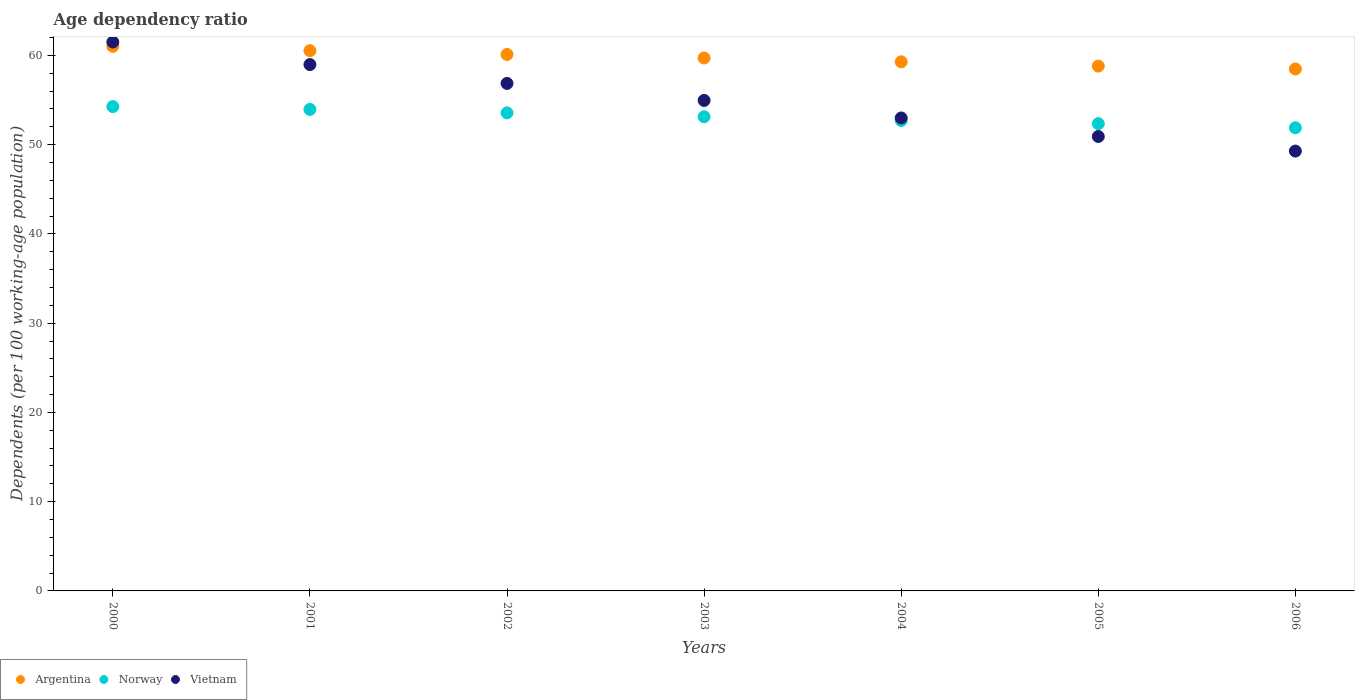Is the number of dotlines equal to the number of legend labels?
Provide a succinct answer. Yes. What is the age dependency ratio in in Argentina in 2004?
Keep it short and to the point. 59.28. Across all years, what is the maximum age dependency ratio in in Argentina?
Give a very brief answer. 61.02. Across all years, what is the minimum age dependency ratio in in Argentina?
Give a very brief answer. 58.48. In which year was the age dependency ratio in in Vietnam maximum?
Make the answer very short. 2000. What is the total age dependency ratio in in Vietnam in the graph?
Offer a very short reply. 385.49. What is the difference between the age dependency ratio in in Argentina in 2002 and that in 2005?
Provide a short and direct response. 1.31. What is the difference between the age dependency ratio in in Norway in 2006 and the age dependency ratio in in Argentina in 2000?
Ensure brevity in your answer.  -9.13. What is the average age dependency ratio in in Norway per year?
Give a very brief answer. 53.12. In the year 2000, what is the difference between the age dependency ratio in in Argentina and age dependency ratio in in Vietnam?
Offer a terse response. -0.48. In how many years, is the age dependency ratio in in Norway greater than 52 %?
Provide a short and direct response. 6. What is the ratio of the age dependency ratio in in Norway in 2002 to that in 2006?
Keep it short and to the point. 1.03. Is the age dependency ratio in in Argentina in 2000 less than that in 2003?
Offer a very short reply. No. Is the difference between the age dependency ratio in in Argentina in 2002 and 2004 greater than the difference between the age dependency ratio in in Vietnam in 2002 and 2004?
Provide a short and direct response. No. What is the difference between the highest and the second highest age dependency ratio in in Argentina?
Keep it short and to the point. 0.49. What is the difference between the highest and the lowest age dependency ratio in in Argentina?
Provide a succinct answer. 2.54. In how many years, is the age dependency ratio in in Vietnam greater than the average age dependency ratio in in Vietnam taken over all years?
Your answer should be compact. 3. Is the sum of the age dependency ratio in in Norway in 2003 and 2005 greater than the maximum age dependency ratio in in Argentina across all years?
Provide a succinct answer. Yes. Is it the case that in every year, the sum of the age dependency ratio in in Argentina and age dependency ratio in in Norway  is greater than the age dependency ratio in in Vietnam?
Make the answer very short. Yes. Is the age dependency ratio in in Argentina strictly greater than the age dependency ratio in in Vietnam over the years?
Offer a very short reply. No. Is the age dependency ratio in in Argentina strictly less than the age dependency ratio in in Vietnam over the years?
Make the answer very short. No. How many years are there in the graph?
Keep it short and to the point. 7. What is the difference between two consecutive major ticks on the Y-axis?
Your answer should be very brief. 10. Are the values on the major ticks of Y-axis written in scientific E-notation?
Ensure brevity in your answer.  No. How many legend labels are there?
Offer a terse response. 3. What is the title of the graph?
Make the answer very short. Age dependency ratio. Does "Upper middle income" appear as one of the legend labels in the graph?
Make the answer very short. No. What is the label or title of the X-axis?
Offer a very short reply. Years. What is the label or title of the Y-axis?
Your answer should be compact. Dependents (per 100 working-age population). What is the Dependents (per 100 working-age population) of Argentina in 2000?
Your response must be concise. 61.02. What is the Dependents (per 100 working-age population) in Norway in 2000?
Ensure brevity in your answer.  54.27. What is the Dependents (per 100 working-age population) of Vietnam in 2000?
Your response must be concise. 61.5. What is the Dependents (per 100 working-age population) of Argentina in 2001?
Offer a very short reply. 60.53. What is the Dependents (per 100 working-age population) in Norway in 2001?
Provide a succinct answer. 53.95. What is the Dependents (per 100 working-age population) of Vietnam in 2001?
Your answer should be very brief. 58.98. What is the Dependents (per 100 working-age population) in Argentina in 2002?
Provide a short and direct response. 60.11. What is the Dependents (per 100 working-age population) of Norway in 2002?
Your answer should be very brief. 53.56. What is the Dependents (per 100 working-age population) of Vietnam in 2002?
Offer a very short reply. 56.86. What is the Dependents (per 100 working-age population) in Argentina in 2003?
Your answer should be compact. 59.71. What is the Dependents (per 100 working-age population) of Norway in 2003?
Your response must be concise. 53.13. What is the Dependents (per 100 working-age population) in Vietnam in 2003?
Offer a very short reply. 54.96. What is the Dependents (per 100 working-age population) in Argentina in 2004?
Provide a short and direct response. 59.28. What is the Dependents (per 100 working-age population) of Norway in 2004?
Make the answer very short. 52.71. What is the Dependents (per 100 working-age population) of Vietnam in 2004?
Give a very brief answer. 52.99. What is the Dependents (per 100 working-age population) in Argentina in 2005?
Give a very brief answer. 58.8. What is the Dependents (per 100 working-age population) of Norway in 2005?
Offer a terse response. 52.36. What is the Dependents (per 100 working-age population) in Vietnam in 2005?
Offer a very short reply. 50.92. What is the Dependents (per 100 working-age population) of Argentina in 2006?
Provide a short and direct response. 58.48. What is the Dependents (per 100 working-age population) in Norway in 2006?
Make the answer very short. 51.89. What is the Dependents (per 100 working-age population) of Vietnam in 2006?
Your response must be concise. 49.28. Across all years, what is the maximum Dependents (per 100 working-age population) of Argentina?
Ensure brevity in your answer.  61.02. Across all years, what is the maximum Dependents (per 100 working-age population) of Norway?
Your answer should be very brief. 54.27. Across all years, what is the maximum Dependents (per 100 working-age population) of Vietnam?
Your response must be concise. 61.5. Across all years, what is the minimum Dependents (per 100 working-age population) in Argentina?
Give a very brief answer. 58.48. Across all years, what is the minimum Dependents (per 100 working-age population) in Norway?
Ensure brevity in your answer.  51.89. Across all years, what is the minimum Dependents (per 100 working-age population) in Vietnam?
Offer a terse response. 49.28. What is the total Dependents (per 100 working-age population) in Argentina in the graph?
Provide a succinct answer. 417.95. What is the total Dependents (per 100 working-age population) in Norway in the graph?
Your answer should be compact. 371.87. What is the total Dependents (per 100 working-age population) of Vietnam in the graph?
Provide a short and direct response. 385.49. What is the difference between the Dependents (per 100 working-age population) of Argentina in 2000 and that in 2001?
Offer a very short reply. 0.49. What is the difference between the Dependents (per 100 working-age population) in Norway in 2000 and that in 2001?
Provide a succinct answer. 0.32. What is the difference between the Dependents (per 100 working-age population) of Vietnam in 2000 and that in 2001?
Your answer should be compact. 2.52. What is the difference between the Dependents (per 100 working-age population) in Argentina in 2000 and that in 2002?
Give a very brief answer. 0.91. What is the difference between the Dependents (per 100 working-age population) in Norway in 2000 and that in 2002?
Offer a very short reply. 0.71. What is the difference between the Dependents (per 100 working-age population) in Vietnam in 2000 and that in 2002?
Your answer should be compact. 4.64. What is the difference between the Dependents (per 100 working-age population) of Argentina in 2000 and that in 2003?
Provide a short and direct response. 1.31. What is the difference between the Dependents (per 100 working-age population) of Norway in 2000 and that in 2003?
Ensure brevity in your answer.  1.14. What is the difference between the Dependents (per 100 working-age population) of Vietnam in 2000 and that in 2003?
Ensure brevity in your answer.  6.54. What is the difference between the Dependents (per 100 working-age population) of Argentina in 2000 and that in 2004?
Your answer should be compact. 1.74. What is the difference between the Dependents (per 100 working-age population) of Norway in 2000 and that in 2004?
Your response must be concise. 1.56. What is the difference between the Dependents (per 100 working-age population) in Vietnam in 2000 and that in 2004?
Give a very brief answer. 8.51. What is the difference between the Dependents (per 100 working-age population) of Argentina in 2000 and that in 2005?
Ensure brevity in your answer.  2.22. What is the difference between the Dependents (per 100 working-age population) of Norway in 2000 and that in 2005?
Your answer should be very brief. 1.91. What is the difference between the Dependents (per 100 working-age population) of Vietnam in 2000 and that in 2005?
Your answer should be compact. 10.59. What is the difference between the Dependents (per 100 working-age population) in Argentina in 2000 and that in 2006?
Your answer should be very brief. 2.54. What is the difference between the Dependents (per 100 working-age population) in Norway in 2000 and that in 2006?
Provide a short and direct response. 2.38. What is the difference between the Dependents (per 100 working-age population) of Vietnam in 2000 and that in 2006?
Your response must be concise. 12.22. What is the difference between the Dependents (per 100 working-age population) of Argentina in 2001 and that in 2002?
Your response must be concise. 0.42. What is the difference between the Dependents (per 100 working-age population) of Norway in 2001 and that in 2002?
Provide a succinct answer. 0.39. What is the difference between the Dependents (per 100 working-age population) in Vietnam in 2001 and that in 2002?
Provide a succinct answer. 2.11. What is the difference between the Dependents (per 100 working-age population) in Argentina in 2001 and that in 2003?
Keep it short and to the point. 0.82. What is the difference between the Dependents (per 100 working-age population) of Norway in 2001 and that in 2003?
Offer a very short reply. 0.82. What is the difference between the Dependents (per 100 working-age population) in Vietnam in 2001 and that in 2003?
Provide a succinct answer. 4.02. What is the difference between the Dependents (per 100 working-age population) of Argentina in 2001 and that in 2004?
Make the answer very short. 1.25. What is the difference between the Dependents (per 100 working-age population) in Norway in 2001 and that in 2004?
Keep it short and to the point. 1.24. What is the difference between the Dependents (per 100 working-age population) in Vietnam in 2001 and that in 2004?
Offer a very short reply. 5.98. What is the difference between the Dependents (per 100 working-age population) of Argentina in 2001 and that in 2005?
Your response must be concise. 1.73. What is the difference between the Dependents (per 100 working-age population) in Norway in 2001 and that in 2005?
Provide a succinct answer. 1.59. What is the difference between the Dependents (per 100 working-age population) in Vietnam in 2001 and that in 2005?
Ensure brevity in your answer.  8.06. What is the difference between the Dependents (per 100 working-age population) of Argentina in 2001 and that in 2006?
Ensure brevity in your answer.  2.05. What is the difference between the Dependents (per 100 working-age population) of Norway in 2001 and that in 2006?
Your response must be concise. 2.06. What is the difference between the Dependents (per 100 working-age population) in Vietnam in 2001 and that in 2006?
Offer a very short reply. 9.7. What is the difference between the Dependents (per 100 working-age population) of Argentina in 2002 and that in 2003?
Provide a succinct answer. 0.4. What is the difference between the Dependents (per 100 working-age population) of Norway in 2002 and that in 2003?
Your response must be concise. 0.43. What is the difference between the Dependents (per 100 working-age population) of Vietnam in 2002 and that in 2003?
Your answer should be very brief. 1.91. What is the difference between the Dependents (per 100 working-age population) of Argentina in 2002 and that in 2004?
Provide a short and direct response. 0.83. What is the difference between the Dependents (per 100 working-age population) in Norway in 2002 and that in 2004?
Give a very brief answer. 0.85. What is the difference between the Dependents (per 100 working-age population) of Vietnam in 2002 and that in 2004?
Keep it short and to the point. 3.87. What is the difference between the Dependents (per 100 working-age population) in Argentina in 2002 and that in 2005?
Keep it short and to the point. 1.31. What is the difference between the Dependents (per 100 working-age population) in Norway in 2002 and that in 2005?
Give a very brief answer. 1.2. What is the difference between the Dependents (per 100 working-age population) of Vietnam in 2002 and that in 2005?
Offer a very short reply. 5.95. What is the difference between the Dependents (per 100 working-age population) in Argentina in 2002 and that in 2006?
Offer a very short reply. 1.63. What is the difference between the Dependents (per 100 working-age population) in Norway in 2002 and that in 2006?
Provide a succinct answer. 1.67. What is the difference between the Dependents (per 100 working-age population) of Vietnam in 2002 and that in 2006?
Your answer should be compact. 7.58. What is the difference between the Dependents (per 100 working-age population) in Argentina in 2003 and that in 2004?
Keep it short and to the point. 0.43. What is the difference between the Dependents (per 100 working-age population) of Norway in 2003 and that in 2004?
Ensure brevity in your answer.  0.42. What is the difference between the Dependents (per 100 working-age population) in Vietnam in 2003 and that in 2004?
Your answer should be very brief. 1.96. What is the difference between the Dependents (per 100 working-age population) in Argentina in 2003 and that in 2005?
Your answer should be very brief. 0.91. What is the difference between the Dependents (per 100 working-age population) in Norway in 2003 and that in 2005?
Your response must be concise. 0.77. What is the difference between the Dependents (per 100 working-age population) of Vietnam in 2003 and that in 2005?
Provide a succinct answer. 4.04. What is the difference between the Dependents (per 100 working-age population) of Argentina in 2003 and that in 2006?
Ensure brevity in your answer.  1.23. What is the difference between the Dependents (per 100 working-age population) of Norway in 2003 and that in 2006?
Your answer should be compact. 1.24. What is the difference between the Dependents (per 100 working-age population) in Vietnam in 2003 and that in 2006?
Offer a terse response. 5.68. What is the difference between the Dependents (per 100 working-age population) in Argentina in 2004 and that in 2005?
Provide a succinct answer. 0.48. What is the difference between the Dependents (per 100 working-age population) of Norway in 2004 and that in 2005?
Your answer should be compact. 0.35. What is the difference between the Dependents (per 100 working-age population) in Vietnam in 2004 and that in 2005?
Make the answer very short. 2.08. What is the difference between the Dependents (per 100 working-age population) in Argentina in 2004 and that in 2006?
Keep it short and to the point. 0.8. What is the difference between the Dependents (per 100 working-age population) in Norway in 2004 and that in 2006?
Your response must be concise. 0.82. What is the difference between the Dependents (per 100 working-age population) in Vietnam in 2004 and that in 2006?
Provide a succinct answer. 3.71. What is the difference between the Dependents (per 100 working-age population) in Argentina in 2005 and that in 2006?
Your response must be concise. 0.32. What is the difference between the Dependents (per 100 working-age population) in Norway in 2005 and that in 2006?
Your response must be concise. 0.47. What is the difference between the Dependents (per 100 working-age population) in Vietnam in 2005 and that in 2006?
Provide a short and direct response. 1.63. What is the difference between the Dependents (per 100 working-age population) of Argentina in 2000 and the Dependents (per 100 working-age population) of Norway in 2001?
Your answer should be compact. 7.07. What is the difference between the Dependents (per 100 working-age population) of Argentina in 2000 and the Dependents (per 100 working-age population) of Vietnam in 2001?
Your answer should be compact. 2.05. What is the difference between the Dependents (per 100 working-age population) of Norway in 2000 and the Dependents (per 100 working-age population) of Vietnam in 2001?
Give a very brief answer. -4.71. What is the difference between the Dependents (per 100 working-age population) of Argentina in 2000 and the Dependents (per 100 working-age population) of Norway in 2002?
Keep it short and to the point. 7.46. What is the difference between the Dependents (per 100 working-age population) in Argentina in 2000 and the Dependents (per 100 working-age population) in Vietnam in 2002?
Offer a terse response. 4.16. What is the difference between the Dependents (per 100 working-age population) of Norway in 2000 and the Dependents (per 100 working-age population) of Vietnam in 2002?
Make the answer very short. -2.6. What is the difference between the Dependents (per 100 working-age population) of Argentina in 2000 and the Dependents (per 100 working-age population) of Norway in 2003?
Provide a succinct answer. 7.89. What is the difference between the Dependents (per 100 working-age population) in Argentina in 2000 and the Dependents (per 100 working-age population) in Vietnam in 2003?
Give a very brief answer. 6.06. What is the difference between the Dependents (per 100 working-age population) in Norway in 2000 and the Dependents (per 100 working-age population) in Vietnam in 2003?
Provide a short and direct response. -0.69. What is the difference between the Dependents (per 100 working-age population) in Argentina in 2000 and the Dependents (per 100 working-age population) in Norway in 2004?
Make the answer very short. 8.31. What is the difference between the Dependents (per 100 working-age population) in Argentina in 2000 and the Dependents (per 100 working-age population) in Vietnam in 2004?
Provide a succinct answer. 8.03. What is the difference between the Dependents (per 100 working-age population) in Norway in 2000 and the Dependents (per 100 working-age population) in Vietnam in 2004?
Your answer should be very brief. 1.27. What is the difference between the Dependents (per 100 working-age population) of Argentina in 2000 and the Dependents (per 100 working-age population) of Norway in 2005?
Offer a terse response. 8.66. What is the difference between the Dependents (per 100 working-age population) of Argentina in 2000 and the Dependents (per 100 working-age population) of Vietnam in 2005?
Keep it short and to the point. 10.11. What is the difference between the Dependents (per 100 working-age population) of Norway in 2000 and the Dependents (per 100 working-age population) of Vietnam in 2005?
Provide a succinct answer. 3.35. What is the difference between the Dependents (per 100 working-age population) in Argentina in 2000 and the Dependents (per 100 working-age population) in Norway in 2006?
Offer a very short reply. 9.13. What is the difference between the Dependents (per 100 working-age population) of Argentina in 2000 and the Dependents (per 100 working-age population) of Vietnam in 2006?
Ensure brevity in your answer.  11.74. What is the difference between the Dependents (per 100 working-age population) of Norway in 2000 and the Dependents (per 100 working-age population) of Vietnam in 2006?
Ensure brevity in your answer.  4.99. What is the difference between the Dependents (per 100 working-age population) in Argentina in 2001 and the Dependents (per 100 working-age population) in Norway in 2002?
Your answer should be very brief. 6.97. What is the difference between the Dependents (per 100 working-age population) of Argentina in 2001 and the Dependents (per 100 working-age population) of Vietnam in 2002?
Make the answer very short. 3.67. What is the difference between the Dependents (per 100 working-age population) in Norway in 2001 and the Dependents (per 100 working-age population) in Vietnam in 2002?
Provide a short and direct response. -2.91. What is the difference between the Dependents (per 100 working-age population) in Argentina in 2001 and the Dependents (per 100 working-age population) in Norway in 2003?
Your response must be concise. 7.4. What is the difference between the Dependents (per 100 working-age population) of Argentina in 2001 and the Dependents (per 100 working-age population) of Vietnam in 2003?
Provide a succinct answer. 5.57. What is the difference between the Dependents (per 100 working-age population) of Norway in 2001 and the Dependents (per 100 working-age population) of Vietnam in 2003?
Your answer should be very brief. -1.01. What is the difference between the Dependents (per 100 working-age population) of Argentina in 2001 and the Dependents (per 100 working-age population) of Norway in 2004?
Offer a very short reply. 7.82. What is the difference between the Dependents (per 100 working-age population) of Argentina in 2001 and the Dependents (per 100 working-age population) of Vietnam in 2004?
Your answer should be compact. 7.54. What is the difference between the Dependents (per 100 working-age population) in Argentina in 2001 and the Dependents (per 100 working-age population) in Norway in 2005?
Provide a succinct answer. 8.17. What is the difference between the Dependents (per 100 working-age population) in Argentina in 2001 and the Dependents (per 100 working-age population) in Vietnam in 2005?
Ensure brevity in your answer.  9.62. What is the difference between the Dependents (per 100 working-age population) in Norway in 2001 and the Dependents (per 100 working-age population) in Vietnam in 2005?
Your response must be concise. 3.04. What is the difference between the Dependents (per 100 working-age population) of Argentina in 2001 and the Dependents (per 100 working-age population) of Norway in 2006?
Provide a short and direct response. 8.64. What is the difference between the Dependents (per 100 working-age population) of Argentina in 2001 and the Dependents (per 100 working-age population) of Vietnam in 2006?
Ensure brevity in your answer.  11.25. What is the difference between the Dependents (per 100 working-age population) of Norway in 2001 and the Dependents (per 100 working-age population) of Vietnam in 2006?
Ensure brevity in your answer.  4.67. What is the difference between the Dependents (per 100 working-age population) in Argentina in 2002 and the Dependents (per 100 working-age population) in Norway in 2003?
Provide a short and direct response. 6.98. What is the difference between the Dependents (per 100 working-age population) of Argentina in 2002 and the Dependents (per 100 working-age population) of Vietnam in 2003?
Provide a succinct answer. 5.15. What is the difference between the Dependents (per 100 working-age population) in Norway in 2002 and the Dependents (per 100 working-age population) in Vietnam in 2003?
Your answer should be compact. -1.4. What is the difference between the Dependents (per 100 working-age population) of Argentina in 2002 and the Dependents (per 100 working-age population) of Norway in 2004?
Offer a terse response. 7.4. What is the difference between the Dependents (per 100 working-age population) in Argentina in 2002 and the Dependents (per 100 working-age population) in Vietnam in 2004?
Keep it short and to the point. 7.12. What is the difference between the Dependents (per 100 working-age population) in Norway in 2002 and the Dependents (per 100 working-age population) in Vietnam in 2004?
Provide a short and direct response. 0.57. What is the difference between the Dependents (per 100 working-age population) in Argentina in 2002 and the Dependents (per 100 working-age population) in Norway in 2005?
Offer a very short reply. 7.75. What is the difference between the Dependents (per 100 working-age population) in Argentina in 2002 and the Dependents (per 100 working-age population) in Vietnam in 2005?
Your response must be concise. 9.2. What is the difference between the Dependents (per 100 working-age population) of Norway in 2002 and the Dependents (per 100 working-age population) of Vietnam in 2005?
Your response must be concise. 2.65. What is the difference between the Dependents (per 100 working-age population) in Argentina in 2002 and the Dependents (per 100 working-age population) in Norway in 2006?
Ensure brevity in your answer.  8.22. What is the difference between the Dependents (per 100 working-age population) of Argentina in 2002 and the Dependents (per 100 working-age population) of Vietnam in 2006?
Provide a succinct answer. 10.83. What is the difference between the Dependents (per 100 working-age population) in Norway in 2002 and the Dependents (per 100 working-age population) in Vietnam in 2006?
Ensure brevity in your answer.  4.28. What is the difference between the Dependents (per 100 working-age population) in Argentina in 2003 and the Dependents (per 100 working-age population) in Norway in 2004?
Ensure brevity in your answer.  7.01. What is the difference between the Dependents (per 100 working-age population) in Argentina in 2003 and the Dependents (per 100 working-age population) in Vietnam in 2004?
Your answer should be very brief. 6.72. What is the difference between the Dependents (per 100 working-age population) of Norway in 2003 and the Dependents (per 100 working-age population) of Vietnam in 2004?
Make the answer very short. 0.13. What is the difference between the Dependents (per 100 working-age population) of Argentina in 2003 and the Dependents (per 100 working-age population) of Norway in 2005?
Provide a short and direct response. 7.36. What is the difference between the Dependents (per 100 working-age population) in Argentina in 2003 and the Dependents (per 100 working-age population) in Vietnam in 2005?
Your answer should be compact. 8.8. What is the difference between the Dependents (per 100 working-age population) in Norway in 2003 and the Dependents (per 100 working-age population) in Vietnam in 2005?
Offer a terse response. 2.21. What is the difference between the Dependents (per 100 working-age population) of Argentina in 2003 and the Dependents (per 100 working-age population) of Norway in 2006?
Offer a very short reply. 7.82. What is the difference between the Dependents (per 100 working-age population) in Argentina in 2003 and the Dependents (per 100 working-age population) in Vietnam in 2006?
Your answer should be very brief. 10.43. What is the difference between the Dependents (per 100 working-age population) in Norway in 2003 and the Dependents (per 100 working-age population) in Vietnam in 2006?
Keep it short and to the point. 3.85. What is the difference between the Dependents (per 100 working-age population) of Argentina in 2004 and the Dependents (per 100 working-age population) of Norway in 2005?
Your answer should be compact. 6.93. What is the difference between the Dependents (per 100 working-age population) of Argentina in 2004 and the Dependents (per 100 working-age population) of Vietnam in 2005?
Offer a terse response. 8.37. What is the difference between the Dependents (per 100 working-age population) of Norway in 2004 and the Dependents (per 100 working-age population) of Vietnam in 2005?
Offer a terse response. 1.79. What is the difference between the Dependents (per 100 working-age population) of Argentina in 2004 and the Dependents (per 100 working-age population) of Norway in 2006?
Keep it short and to the point. 7.39. What is the difference between the Dependents (per 100 working-age population) of Argentina in 2004 and the Dependents (per 100 working-age population) of Vietnam in 2006?
Provide a short and direct response. 10. What is the difference between the Dependents (per 100 working-age population) of Norway in 2004 and the Dependents (per 100 working-age population) of Vietnam in 2006?
Make the answer very short. 3.43. What is the difference between the Dependents (per 100 working-age population) in Argentina in 2005 and the Dependents (per 100 working-age population) in Norway in 2006?
Provide a succinct answer. 6.91. What is the difference between the Dependents (per 100 working-age population) in Argentina in 2005 and the Dependents (per 100 working-age population) in Vietnam in 2006?
Your answer should be very brief. 9.52. What is the difference between the Dependents (per 100 working-age population) of Norway in 2005 and the Dependents (per 100 working-age population) of Vietnam in 2006?
Provide a succinct answer. 3.08. What is the average Dependents (per 100 working-age population) of Argentina per year?
Ensure brevity in your answer.  59.71. What is the average Dependents (per 100 working-age population) of Norway per year?
Offer a terse response. 53.12. What is the average Dependents (per 100 working-age population) in Vietnam per year?
Provide a short and direct response. 55.07. In the year 2000, what is the difference between the Dependents (per 100 working-age population) of Argentina and Dependents (per 100 working-age population) of Norway?
Give a very brief answer. 6.75. In the year 2000, what is the difference between the Dependents (per 100 working-age population) of Argentina and Dependents (per 100 working-age population) of Vietnam?
Offer a terse response. -0.48. In the year 2000, what is the difference between the Dependents (per 100 working-age population) in Norway and Dependents (per 100 working-age population) in Vietnam?
Make the answer very short. -7.23. In the year 2001, what is the difference between the Dependents (per 100 working-age population) in Argentina and Dependents (per 100 working-age population) in Norway?
Keep it short and to the point. 6.58. In the year 2001, what is the difference between the Dependents (per 100 working-age population) of Argentina and Dependents (per 100 working-age population) of Vietnam?
Give a very brief answer. 1.56. In the year 2001, what is the difference between the Dependents (per 100 working-age population) in Norway and Dependents (per 100 working-age population) in Vietnam?
Offer a terse response. -5.03. In the year 2002, what is the difference between the Dependents (per 100 working-age population) in Argentina and Dependents (per 100 working-age population) in Norway?
Your answer should be compact. 6.55. In the year 2002, what is the difference between the Dependents (per 100 working-age population) in Argentina and Dependents (per 100 working-age population) in Vietnam?
Make the answer very short. 3.25. In the year 2002, what is the difference between the Dependents (per 100 working-age population) in Norway and Dependents (per 100 working-age population) in Vietnam?
Provide a succinct answer. -3.3. In the year 2003, what is the difference between the Dependents (per 100 working-age population) of Argentina and Dependents (per 100 working-age population) of Norway?
Provide a short and direct response. 6.59. In the year 2003, what is the difference between the Dependents (per 100 working-age population) in Argentina and Dependents (per 100 working-age population) in Vietnam?
Ensure brevity in your answer.  4.76. In the year 2003, what is the difference between the Dependents (per 100 working-age population) of Norway and Dependents (per 100 working-age population) of Vietnam?
Provide a succinct answer. -1.83. In the year 2004, what is the difference between the Dependents (per 100 working-age population) in Argentina and Dependents (per 100 working-age population) in Norway?
Your answer should be compact. 6.58. In the year 2004, what is the difference between the Dependents (per 100 working-age population) in Argentina and Dependents (per 100 working-age population) in Vietnam?
Provide a succinct answer. 6.29. In the year 2004, what is the difference between the Dependents (per 100 working-age population) in Norway and Dependents (per 100 working-age population) in Vietnam?
Make the answer very short. -0.28. In the year 2005, what is the difference between the Dependents (per 100 working-age population) in Argentina and Dependents (per 100 working-age population) in Norway?
Your response must be concise. 6.45. In the year 2005, what is the difference between the Dependents (per 100 working-age population) in Argentina and Dependents (per 100 working-age population) in Vietnam?
Provide a short and direct response. 7.89. In the year 2005, what is the difference between the Dependents (per 100 working-age population) of Norway and Dependents (per 100 working-age population) of Vietnam?
Give a very brief answer. 1.44. In the year 2006, what is the difference between the Dependents (per 100 working-age population) of Argentina and Dependents (per 100 working-age population) of Norway?
Provide a succinct answer. 6.59. In the year 2006, what is the difference between the Dependents (per 100 working-age population) of Argentina and Dependents (per 100 working-age population) of Vietnam?
Your answer should be compact. 9.2. In the year 2006, what is the difference between the Dependents (per 100 working-age population) in Norway and Dependents (per 100 working-age population) in Vietnam?
Give a very brief answer. 2.61. What is the ratio of the Dependents (per 100 working-age population) in Argentina in 2000 to that in 2001?
Your answer should be compact. 1.01. What is the ratio of the Dependents (per 100 working-age population) of Norway in 2000 to that in 2001?
Offer a terse response. 1.01. What is the ratio of the Dependents (per 100 working-age population) of Vietnam in 2000 to that in 2001?
Ensure brevity in your answer.  1.04. What is the ratio of the Dependents (per 100 working-age population) of Argentina in 2000 to that in 2002?
Offer a terse response. 1.02. What is the ratio of the Dependents (per 100 working-age population) of Norway in 2000 to that in 2002?
Offer a terse response. 1.01. What is the ratio of the Dependents (per 100 working-age population) of Vietnam in 2000 to that in 2002?
Keep it short and to the point. 1.08. What is the ratio of the Dependents (per 100 working-age population) of Argentina in 2000 to that in 2003?
Your response must be concise. 1.02. What is the ratio of the Dependents (per 100 working-age population) in Norway in 2000 to that in 2003?
Your response must be concise. 1.02. What is the ratio of the Dependents (per 100 working-age population) in Vietnam in 2000 to that in 2003?
Give a very brief answer. 1.12. What is the ratio of the Dependents (per 100 working-age population) in Argentina in 2000 to that in 2004?
Provide a short and direct response. 1.03. What is the ratio of the Dependents (per 100 working-age population) of Norway in 2000 to that in 2004?
Your answer should be very brief. 1.03. What is the ratio of the Dependents (per 100 working-age population) of Vietnam in 2000 to that in 2004?
Provide a short and direct response. 1.16. What is the ratio of the Dependents (per 100 working-age population) in Argentina in 2000 to that in 2005?
Provide a short and direct response. 1.04. What is the ratio of the Dependents (per 100 working-age population) in Norway in 2000 to that in 2005?
Your response must be concise. 1.04. What is the ratio of the Dependents (per 100 working-age population) in Vietnam in 2000 to that in 2005?
Provide a short and direct response. 1.21. What is the ratio of the Dependents (per 100 working-age population) of Argentina in 2000 to that in 2006?
Keep it short and to the point. 1.04. What is the ratio of the Dependents (per 100 working-age population) of Norway in 2000 to that in 2006?
Your response must be concise. 1.05. What is the ratio of the Dependents (per 100 working-age population) of Vietnam in 2000 to that in 2006?
Provide a succinct answer. 1.25. What is the ratio of the Dependents (per 100 working-age population) of Argentina in 2001 to that in 2002?
Your answer should be compact. 1.01. What is the ratio of the Dependents (per 100 working-age population) of Norway in 2001 to that in 2002?
Offer a terse response. 1.01. What is the ratio of the Dependents (per 100 working-age population) in Vietnam in 2001 to that in 2002?
Your response must be concise. 1.04. What is the ratio of the Dependents (per 100 working-age population) in Argentina in 2001 to that in 2003?
Provide a short and direct response. 1.01. What is the ratio of the Dependents (per 100 working-age population) in Norway in 2001 to that in 2003?
Make the answer very short. 1.02. What is the ratio of the Dependents (per 100 working-age population) of Vietnam in 2001 to that in 2003?
Your answer should be compact. 1.07. What is the ratio of the Dependents (per 100 working-age population) of Norway in 2001 to that in 2004?
Offer a very short reply. 1.02. What is the ratio of the Dependents (per 100 working-age population) of Vietnam in 2001 to that in 2004?
Make the answer very short. 1.11. What is the ratio of the Dependents (per 100 working-age population) in Argentina in 2001 to that in 2005?
Make the answer very short. 1.03. What is the ratio of the Dependents (per 100 working-age population) of Norway in 2001 to that in 2005?
Give a very brief answer. 1.03. What is the ratio of the Dependents (per 100 working-age population) of Vietnam in 2001 to that in 2005?
Your answer should be compact. 1.16. What is the ratio of the Dependents (per 100 working-age population) in Argentina in 2001 to that in 2006?
Give a very brief answer. 1.03. What is the ratio of the Dependents (per 100 working-age population) in Norway in 2001 to that in 2006?
Make the answer very short. 1.04. What is the ratio of the Dependents (per 100 working-age population) of Vietnam in 2001 to that in 2006?
Make the answer very short. 1.2. What is the ratio of the Dependents (per 100 working-age population) in Argentina in 2002 to that in 2003?
Keep it short and to the point. 1.01. What is the ratio of the Dependents (per 100 working-age population) in Norway in 2002 to that in 2003?
Ensure brevity in your answer.  1.01. What is the ratio of the Dependents (per 100 working-age population) in Vietnam in 2002 to that in 2003?
Your answer should be compact. 1.03. What is the ratio of the Dependents (per 100 working-age population) in Argentina in 2002 to that in 2004?
Provide a succinct answer. 1.01. What is the ratio of the Dependents (per 100 working-age population) of Norway in 2002 to that in 2004?
Offer a terse response. 1.02. What is the ratio of the Dependents (per 100 working-age population) in Vietnam in 2002 to that in 2004?
Your response must be concise. 1.07. What is the ratio of the Dependents (per 100 working-age population) in Argentina in 2002 to that in 2005?
Offer a terse response. 1.02. What is the ratio of the Dependents (per 100 working-age population) in Norway in 2002 to that in 2005?
Provide a short and direct response. 1.02. What is the ratio of the Dependents (per 100 working-age population) of Vietnam in 2002 to that in 2005?
Provide a succinct answer. 1.12. What is the ratio of the Dependents (per 100 working-age population) of Argentina in 2002 to that in 2006?
Offer a very short reply. 1.03. What is the ratio of the Dependents (per 100 working-age population) in Norway in 2002 to that in 2006?
Your answer should be very brief. 1.03. What is the ratio of the Dependents (per 100 working-age population) of Vietnam in 2002 to that in 2006?
Make the answer very short. 1.15. What is the ratio of the Dependents (per 100 working-age population) of Argentina in 2003 to that in 2004?
Provide a succinct answer. 1.01. What is the ratio of the Dependents (per 100 working-age population) of Norway in 2003 to that in 2004?
Offer a terse response. 1.01. What is the ratio of the Dependents (per 100 working-age population) of Vietnam in 2003 to that in 2004?
Your answer should be compact. 1.04. What is the ratio of the Dependents (per 100 working-age population) in Argentina in 2003 to that in 2005?
Keep it short and to the point. 1.02. What is the ratio of the Dependents (per 100 working-age population) of Norway in 2003 to that in 2005?
Your response must be concise. 1.01. What is the ratio of the Dependents (per 100 working-age population) in Vietnam in 2003 to that in 2005?
Provide a succinct answer. 1.08. What is the ratio of the Dependents (per 100 working-age population) of Argentina in 2003 to that in 2006?
Your answer should be compact. 1.02. What is the ratio of the Dependents (per 100 working-age population) in Norway in 2003 to that in 2006?
Provide a succinct answer. 1.02. What is the ratio of the Dependents (per 100 working-age population) of Vietnam in 2003 to that in 2006?
Offer a terse response. 1.12. What is the ratio of the Dependents (per 100 working-age population) in Argentina in 2004 to that in 2005?
Your response must be concise. 1.01. What is the ratio of the Dependents (per 100 working-age population) in Vietnam in 2004 to that in 2005?
Keep it short and to the point. 1.04. What is the ratio of the Dependents (per 100 working-age population) in Argentina in 2004 to that in 2006?
Give a very brief answer. 1.01. What is the ratio of the Dependents (per 100 working-age population) in Norway in 2004 to that in 2006?
Your answer should be very brief. 1.02. What is the ratio of the Dependents (per 100 working-age population) of Vietnam in 2004 to that in 2006?
Provide a succinct answer. 1.08. What is the ratio of the Dependents (per 100 working-age population) in Vietnam in 2005 to that in 2006?
Your response must be concise. 1.03. What is the difference between the highest and the second highest Dependents (per 100 working-age population) in Argentina?
Offer a very short reply. 0.49. What is the difference between the highest and the second highest Dependents (per 100 working-age population) in Norway?
Make the answer very short. 0.32. What is the difference between the highest and the second highest Dependents (per 100 working-age population) in Vietnam?
Ensure brevity in your answer.  2.52. What is the difference between the highest and the lowest Dependents (per 100 working-age population) in Argentina?
Your answer should be compact. 2.54. What is the difference between the highest and the lowest Dependents (per 100 working-age population) of Norway?
Provide a succinct answer. 2.38. What is the difference between the highest and the lowest Dependents (per 100 working-age population) of Vietnam?
Provide a short and direct response. 12.22. 